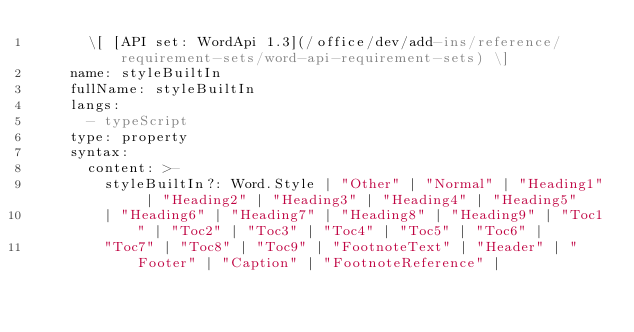<code> <loc_0><loc_0><loc_500><loc_500><_YAML_>      \[ [API set: WordApi 1.3](/office/dev/add-ins/reference/requirement-sets/word-api-requirement-sets) \]
    name: styleBuiltIn
    fullName: styleBuiltIn
    langs:
      - typeScript
    type: property
    syntax:
      content: >-
        styleBuiltIn?: Word.Style | "Other" | "Normal" | "Heading1" | "Heading2" | "Heading3" | "Heading4" | "Heading5"
        | "Heading6" | "Heading7" | "Heading8" | "Heading9" | "Toc1" | "Toc2" | "Toc3" | "Toc4" | "Toc5" | "Toc6" |
        "Toc7" | "Toc8" | "Toc9" | "FootnoteText" | "Header" | "Footer" | "Caption" | "FootnoteReference" |</code> 